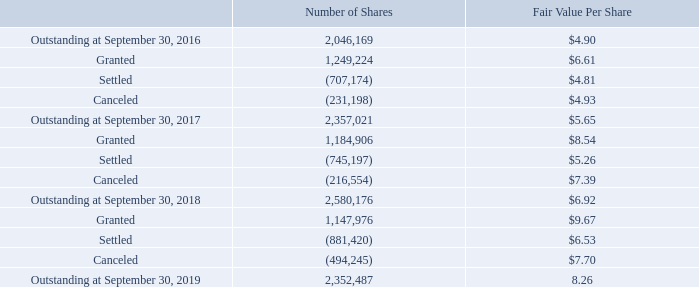Restricted Stock Units
The following table summarizes RSU activity in the fiscal years ended September 30, 2019, 2018, and 2017:
The cost of RSUs is determined using the fair value of the Company’s Common Stock on the award date, and the compensation expense is recognized ratably over the vesting period. The Company recognized $6.8 million, $5.9 million, and $4.0 million in stock-based compensation expense related to outstanding RSUs in the fiscal years ended September 30, 2019, 2018, and 2017, respectively. As of September 30, 2019, the Company had approximately $12.2 million of unrecognized compensation expense related to outstanding RSUs expected to be recognized over a weighted-average period of approximately 2.3 years.
How is the cost of the Restricted Stock Units (RSUs) determined? Using the fair value of the company’s common stock on the award date. How much were the stock-based compensation expenses related to outstanding RSUs in fiscal years 2018 and 2019, respectively? $5.9 million, $6.8 million. What was the number of shares outstanding on September 30, 2016, and 2017, respectively? 2,046,169, 2,357,021. What is the proportion of RSUs that were settled or canceled between 2017 and 2018 over RSUs outstanding on September 30, 2017? (745,197+216,554)/2,357,021 
Answer: 0.41. What is the ratio of the price of RSUs that were granted to the price of RSUs that were settled between 2018 and 2019? (1,147,976*9.67)/(881,420*6.53) 
Answer: 1.93. What is the price of RSUs outstanding on September 30, 2019? 2,352,487*8.26 
Answer: 19431542.62. 